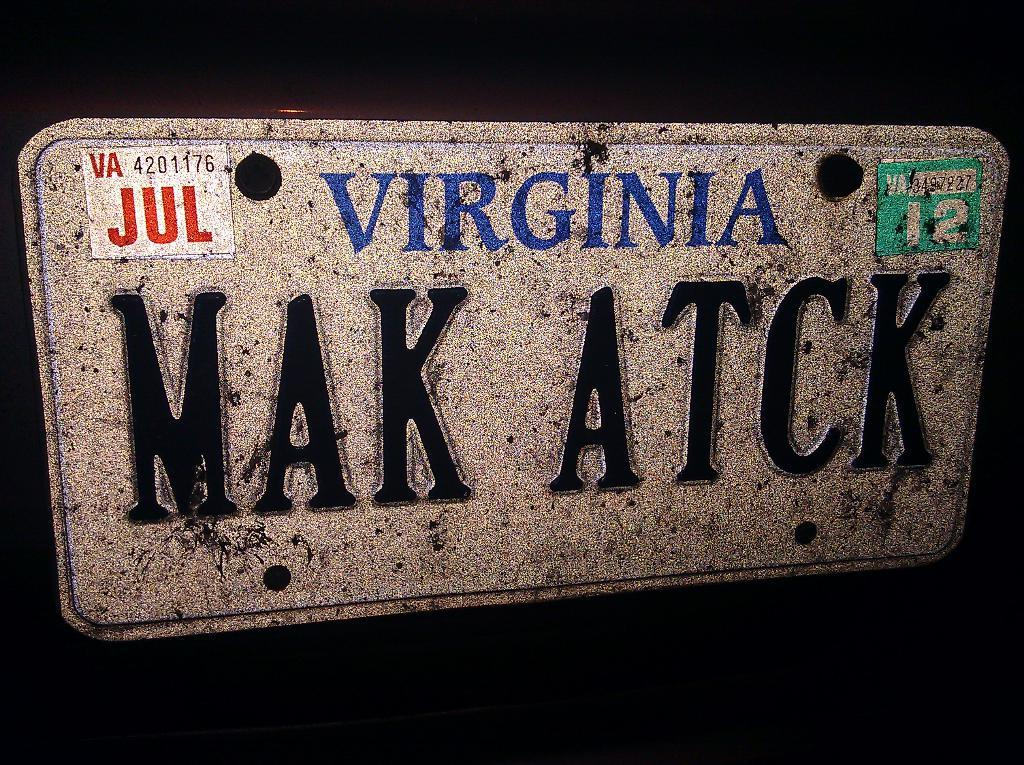What object in the image has a name? There is a nameplate in the image. How is the nameplate attached to its surface? The nameplate has bolts. What other objects are present in the image besides the nameplate? There are stickers on a board in the image. What type of feather can be seen on the nameplate in the image? There is no feather present on the nameplate in the image. How is the brother related to the nameplate in the image? There is no reference to a brother in the image, so it's not possible to determine any relationship. 